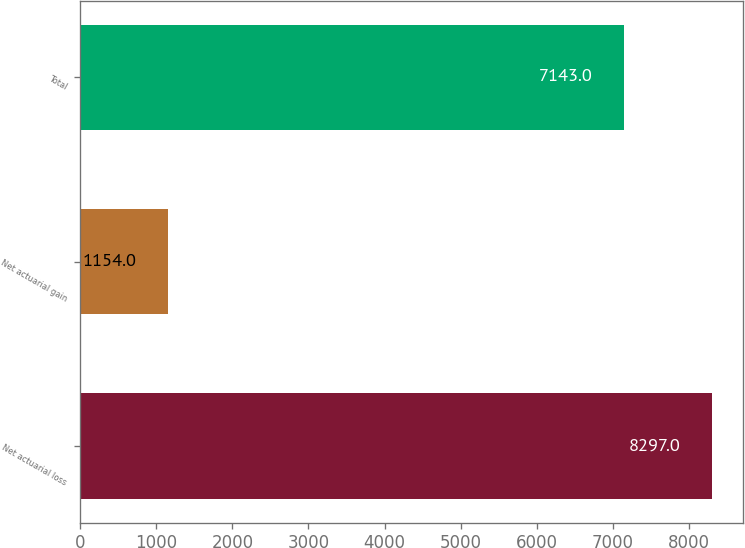Convert chart to OTSL. <chart><loc_0><loc_0><loc_500><loc_500><bar_chart><fcel>Net actuarial loss<fcel>Net actuarial gain<fcel>Total<nl><fcel>8297<fcel>1154<fcel>7143<nl></chart> 